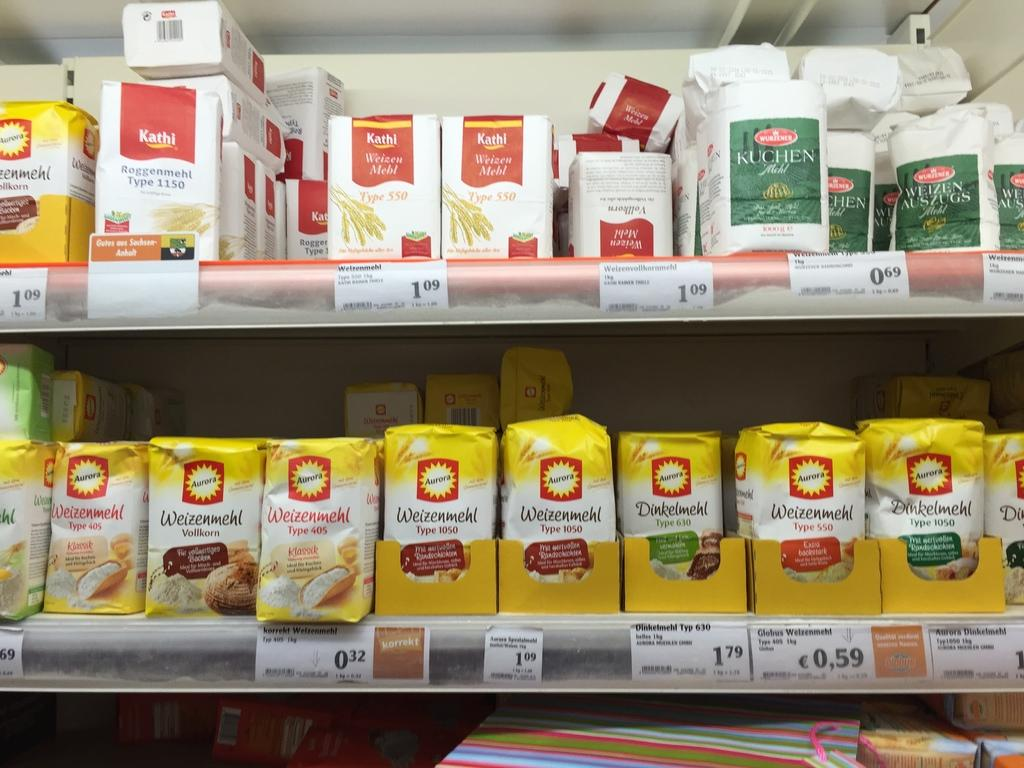<image>
Relay a brief, clear account of the picture shown. Products on a store shelf, that says Weizenmehl type 40's and Kathi Weizen Mebl. 